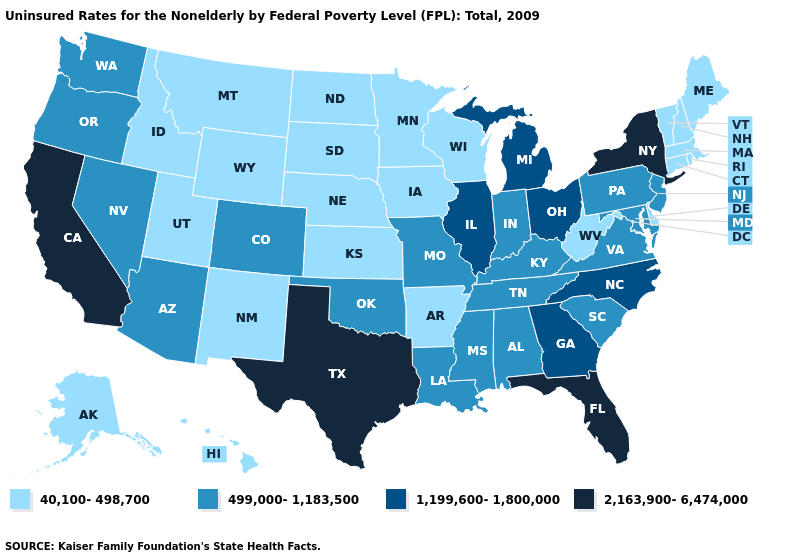Does Washington have a higher value than Illinois?
Keep it brief. No. What is the value of Delaware?
Quick response, please. 40,100-498,700. Among the states that border South Carolina , which have the highest value?
Be succinct. Georgia, North Carolina. Does the first symbol in the legend represent the smallest category?
Concise answer only. Yes. Which states hav the highest value in the West?
Concise answer only. California. What is the highest value in the USA?
Short answer required. 2,163,900-6,474,000. Name the states that have a value in the range 40,100-498,700?
Give a very brief answer. Alaska, Arkansas, Connecticut, Delaware, Hawaii, Idaho, Iowa, Kansas, Maine, Massachusetts, Minnesota, Montana, Nebraska, New Hampshire, New Mexico, North Dakota, Rhode Island, South Dakota, Utah, Vermont, West Virginia, Wisconsin, Wyoming. Does Florida have the highest value in the USA?
Concise answer only. Yes. Among the states that border West Virginia , which have the lowest value?
Keep it brief. Kentucky, Maryland, Pennsylvania, Virginia. Which states hav the highest value in the MidWest?
Give a very brief answer. Illinois, Michigan, Ohio. Name the states that have a value in the range 2,163,900-6,474,000?
Answer briefly. California, Florida, New York, Texas. Does Iowa have the lowest value in the USA?
Concise answer only. Yes. Does Ohio have the same value as Illinois?
Give a very brief answer. Yes. What is the value of Delaware?
Short answer required. 40,100-498,700. Name the states that have a value in the range 1,199,600-1,800,000?
Quick response, please. Georgia, Illinois, Michigan, North Carolina, Ohio. 